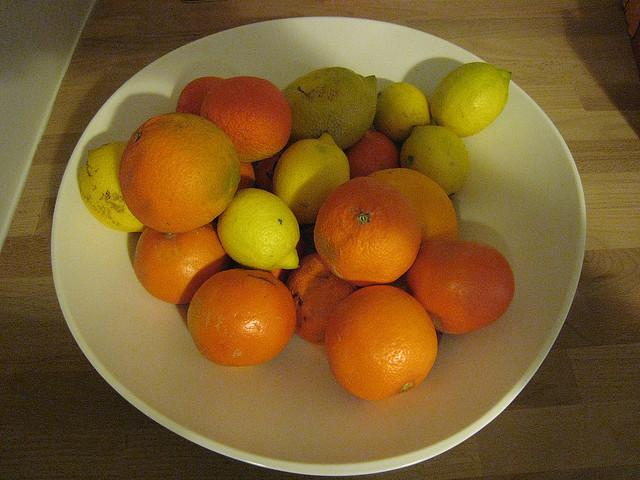Where do lemons originally come from?

Choices:
A) wales
B) unknown
C) ethiopia
D) france unknown 